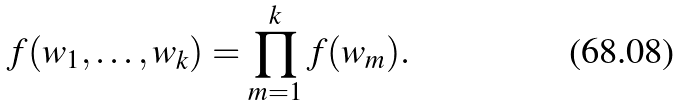<formula> <loc_0><loc_0><loc_500><loc_500>f ( w _ { 1 } , \dots , w _ { k } ) = \prod _ { m = 1 } ^ { k } f ( w _ { m } ) .</formula> 